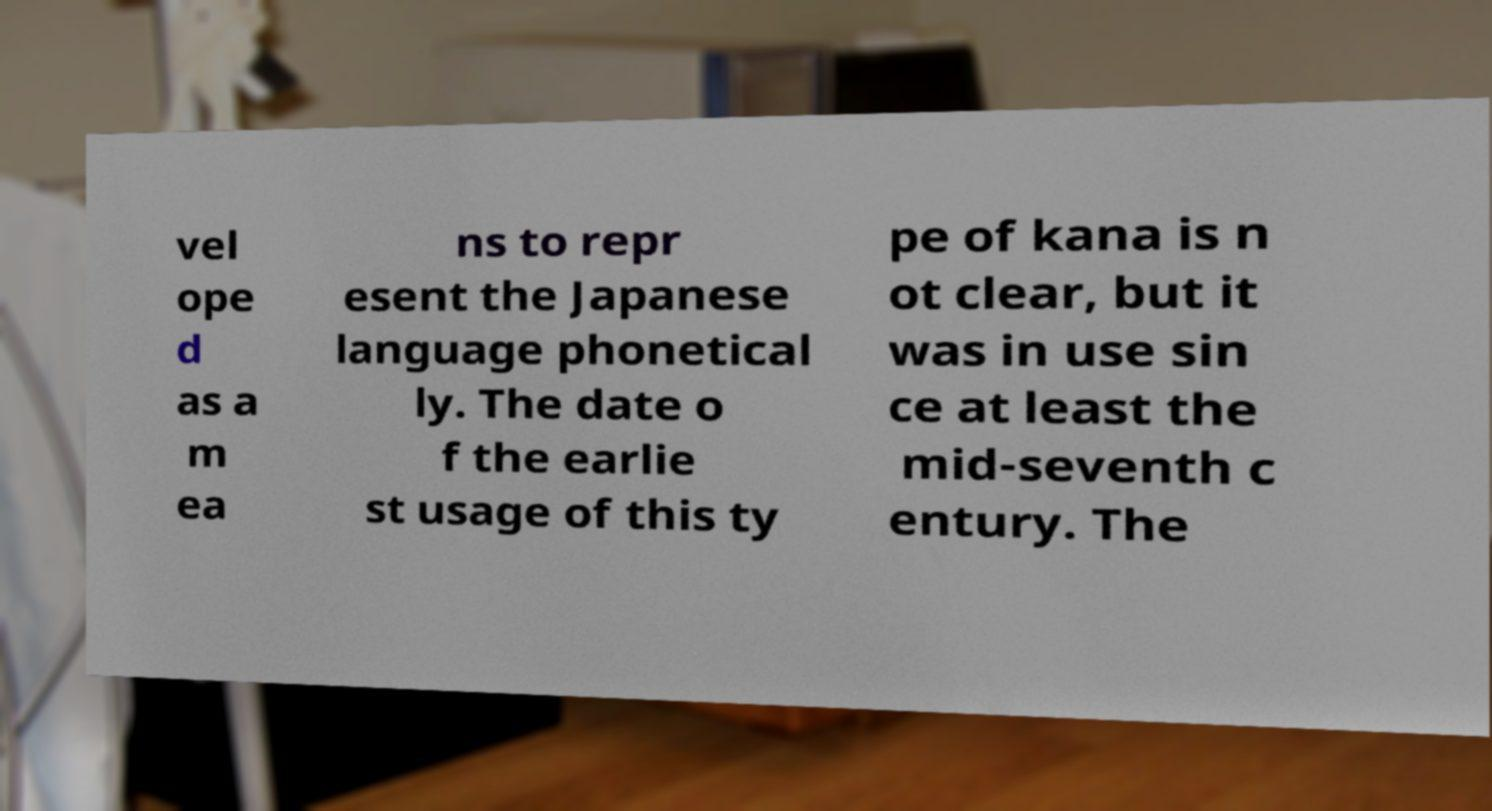Could you extract and type out the text from this image? vel ope d as a m ea ns to repr esent the Japanese language phonetical ly. The date o f the earlie st usage of this ty pe of kana is n ot clear, but it was in use sin ce at least the mid-seventh c entury. The 